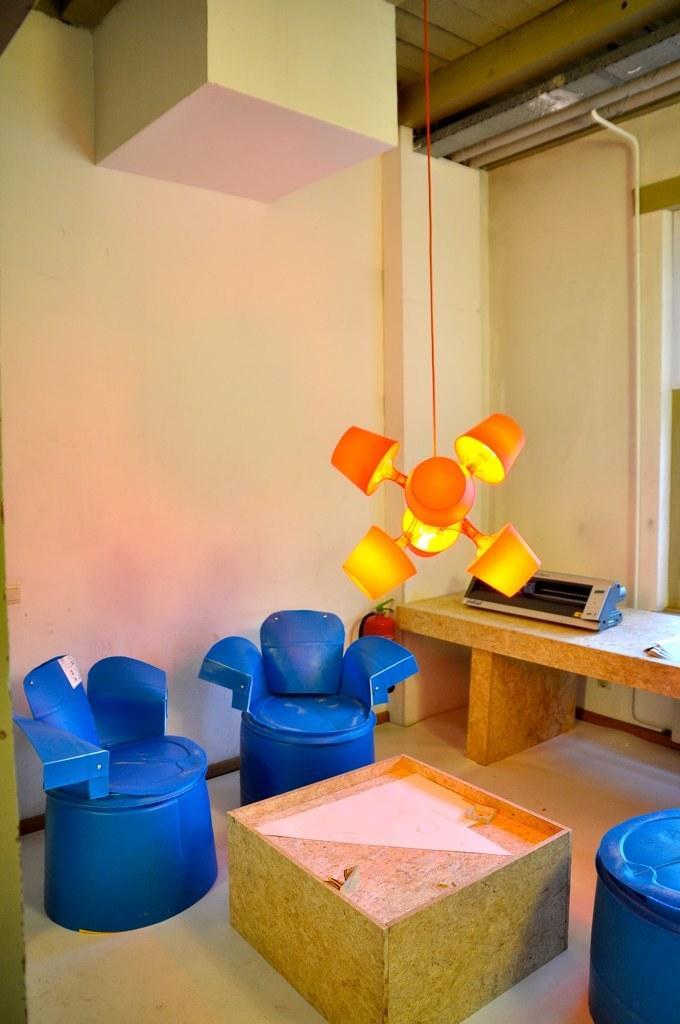In one or two sentences, can you explain what this image depicts? In this picture there is a inside of the room. In the front there is a blue color plastic tables chairs. In the front there is a wooden center table box. Behind there is a printer box on the shelf and yellow color wall. On the top ceiling there are some concealed pipe. 